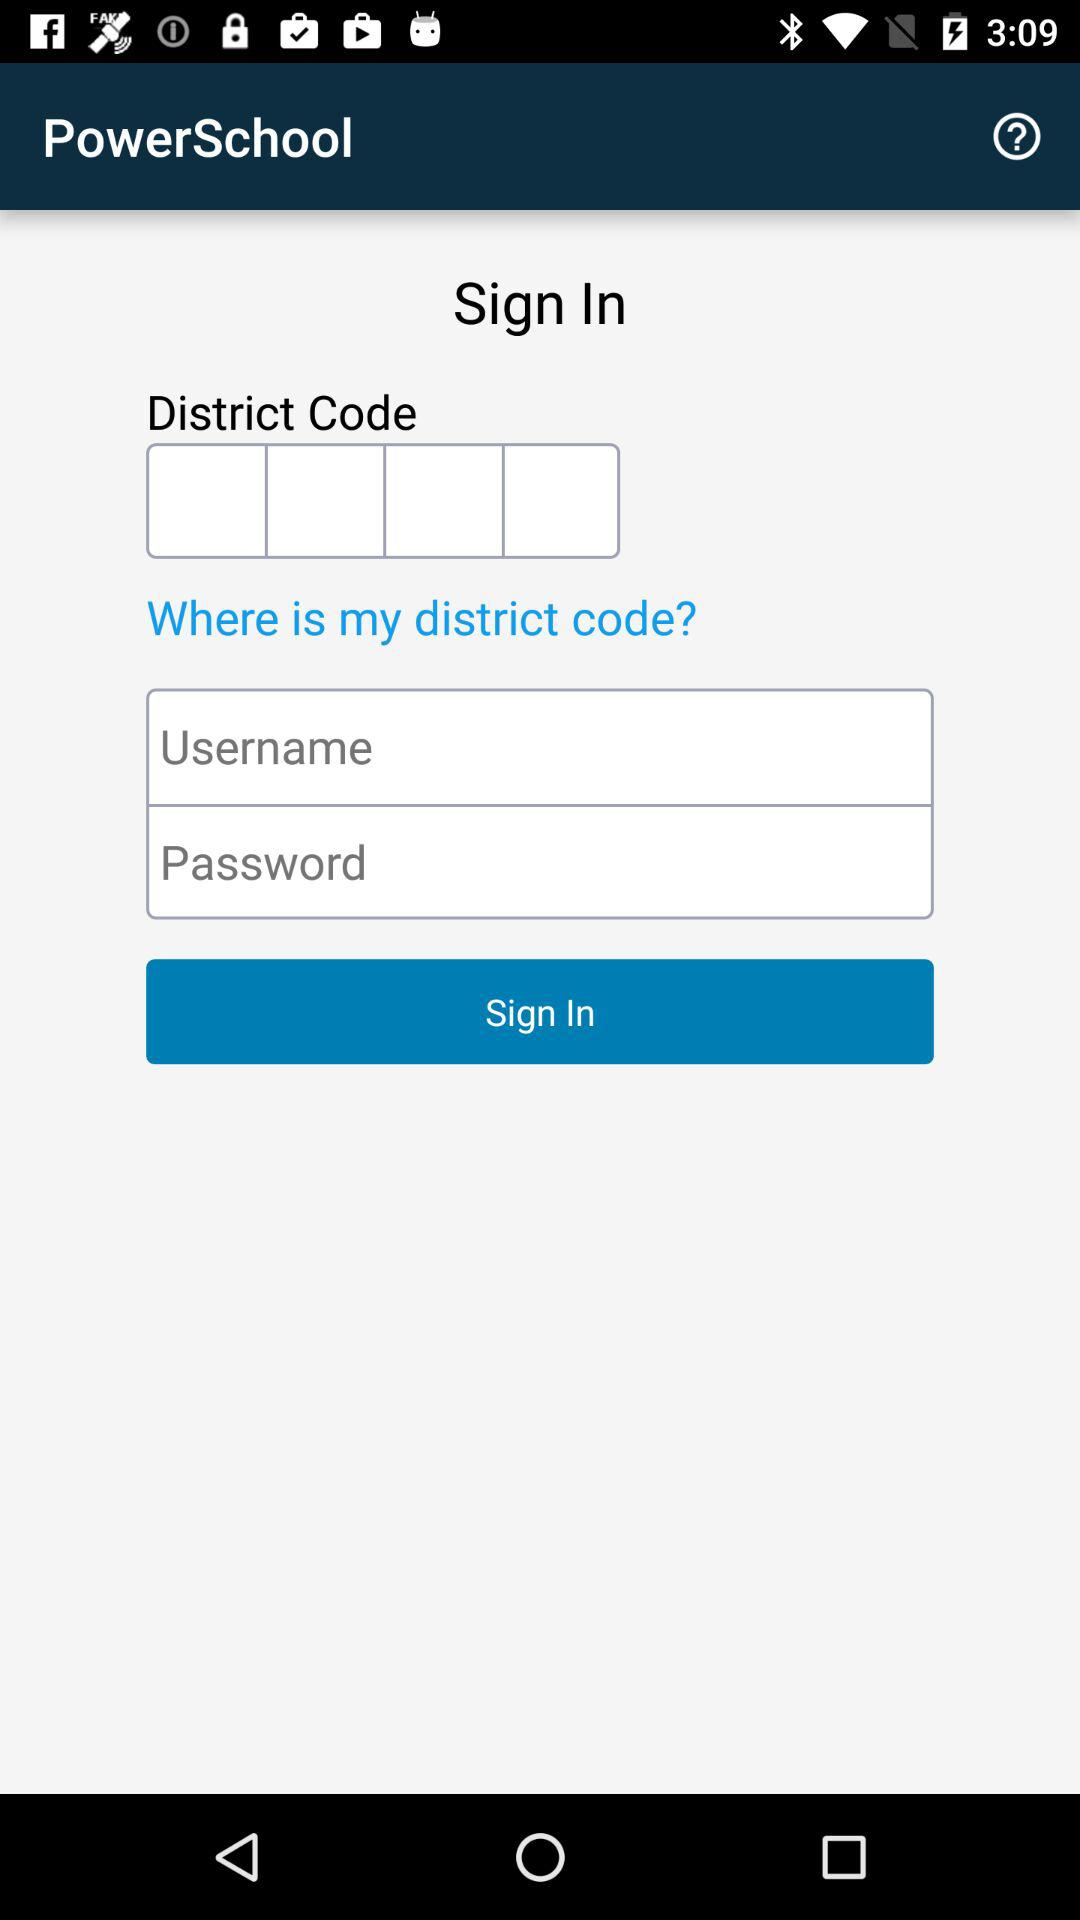What is the username?
When the provided information is insufficient, respond with <no answer>. <no answer> 